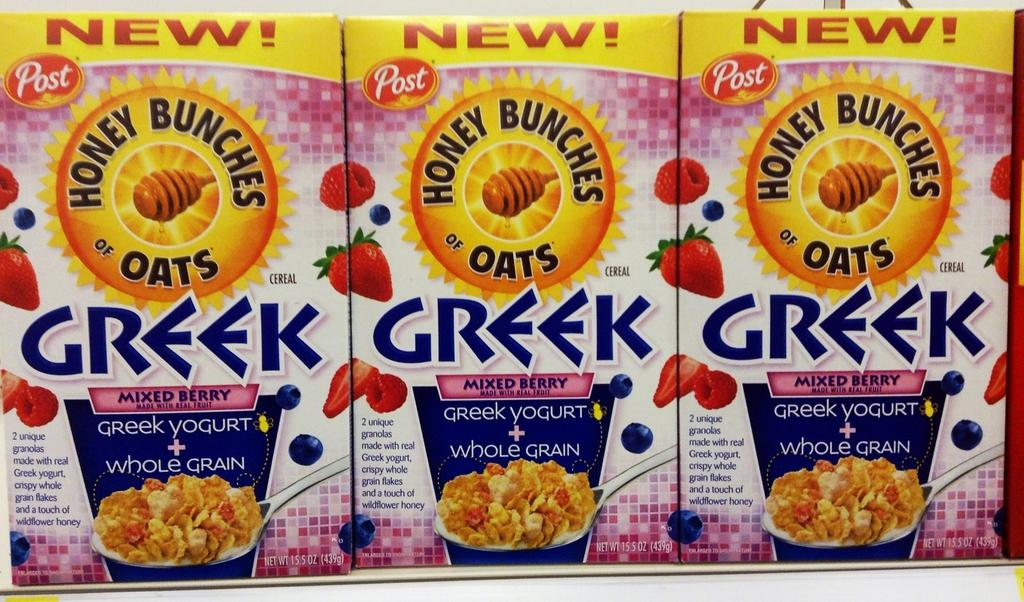What type of objects are featured in the picture? There are edible product boxes in the picture. What can be seen on the surface of the boxes? The boxes have images on them. What information is provided on the boxes? There is text written on the boxes. What type of insect can be seen flying near the boxes in the image? There is no insect present in the image; it only features edible product boxes with images and text. 